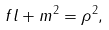<formula> <loc_0><loc_0><loc_500><loc_500>f l + m ^ { 2 } = { \rho } ^ { 2 } ,</formula> 